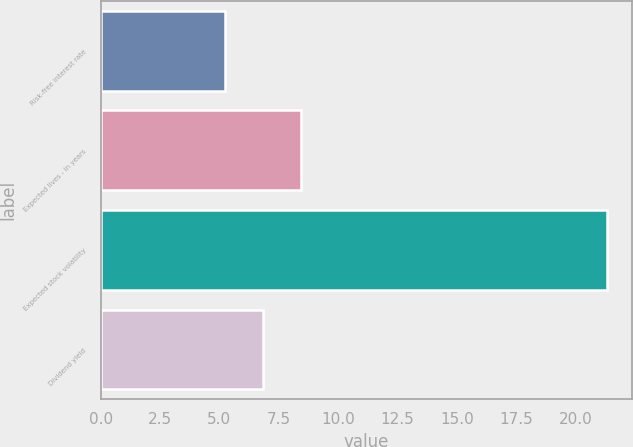Convert chart to OTSL. <chart><loc_0><loc_0><loc_500><loc_500><bar_chart><fcel>Risk-free interest rate<fcel>Expected lives - in years<fcel>Expected stock volatility<fcel>Dividend yield<nl><fcel>5.22<fcel>8.44<fcel>21.32<fcel>6.83<nl></chart> 